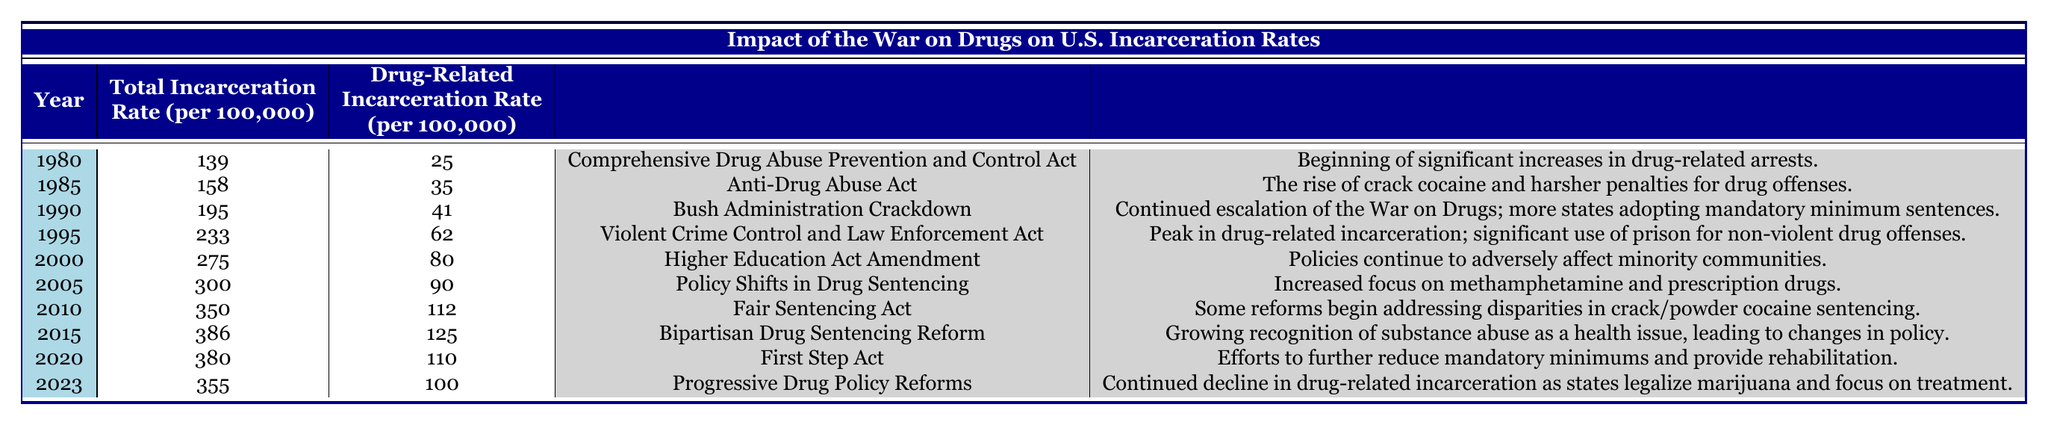What was the total incarceration rate in 1995? The table shows that the total incarceration rate for the year 1995 is listed as 233.
Answer: 233 What significant legislation was enacted in 2010? According to the table, the significant legislation in 2010 was the Fair Sentencing Act.
Answer: Fair Sentencing Act What is the difference in drug-related incarceration rates between 1980 and 1995? For 1980, the drug-related incarceration rate was 25, and for 1995, it was 62. The difference is 62 - 25 = 37.
Answer: 37 In which year was the total incarceration rate the highest? The table indicates that the highest total incarceration rate occurred in 2015, where it was 386.
Answer: 2015 Was there any year after 2010 that saw a decrease in drug-related incarceration rates? By comparing the drug-related incarceration rates from 2010 (112) to subsequent years, we see that both 2020 (110) and 2023 (100) had lower rates. Therefore, yes, there were decreases in those years.
Answer: Yes What is the average total incarceration rate from 1980 to 2023? To find the average total incarceration rate, we add up all the rates: (139 + 158 + 195 + 233 + 275 + 300 + 350 + 386 + 380 + 355) = 2871. There are 10 years, so the average is 2871 / 10 = 287.1.
Answer: 287.1 What percentage of the total incarceration in 2005 was related to drug offenses? In 2005, the total incarceration rate was 300, and the drug-related incarceration rate was 90. The percentage is calculated as (90 / 300) * 100 = 30%.
Answer: 30% Which year experienced the peak in drug-related incarceration, and what was the rate? The peak in drug-related incarceration occurred in 2015, with a rate of 125.
Answer: 2015, 125 Did the significant legislation always result in increases in drug-related incarceration rates? While many legislations correspond to increases in incarceration rates, the comparison shows that from 2010 to 2023, the rates decreased despite significant legislative changes. So, no, not always.
Answer: No What contextual note is provided for the year 2000? The table states that in 2000, the note is about policies continuing to adversely affect minority communities.
Answer: Policies continue to adversely affect minority communities 